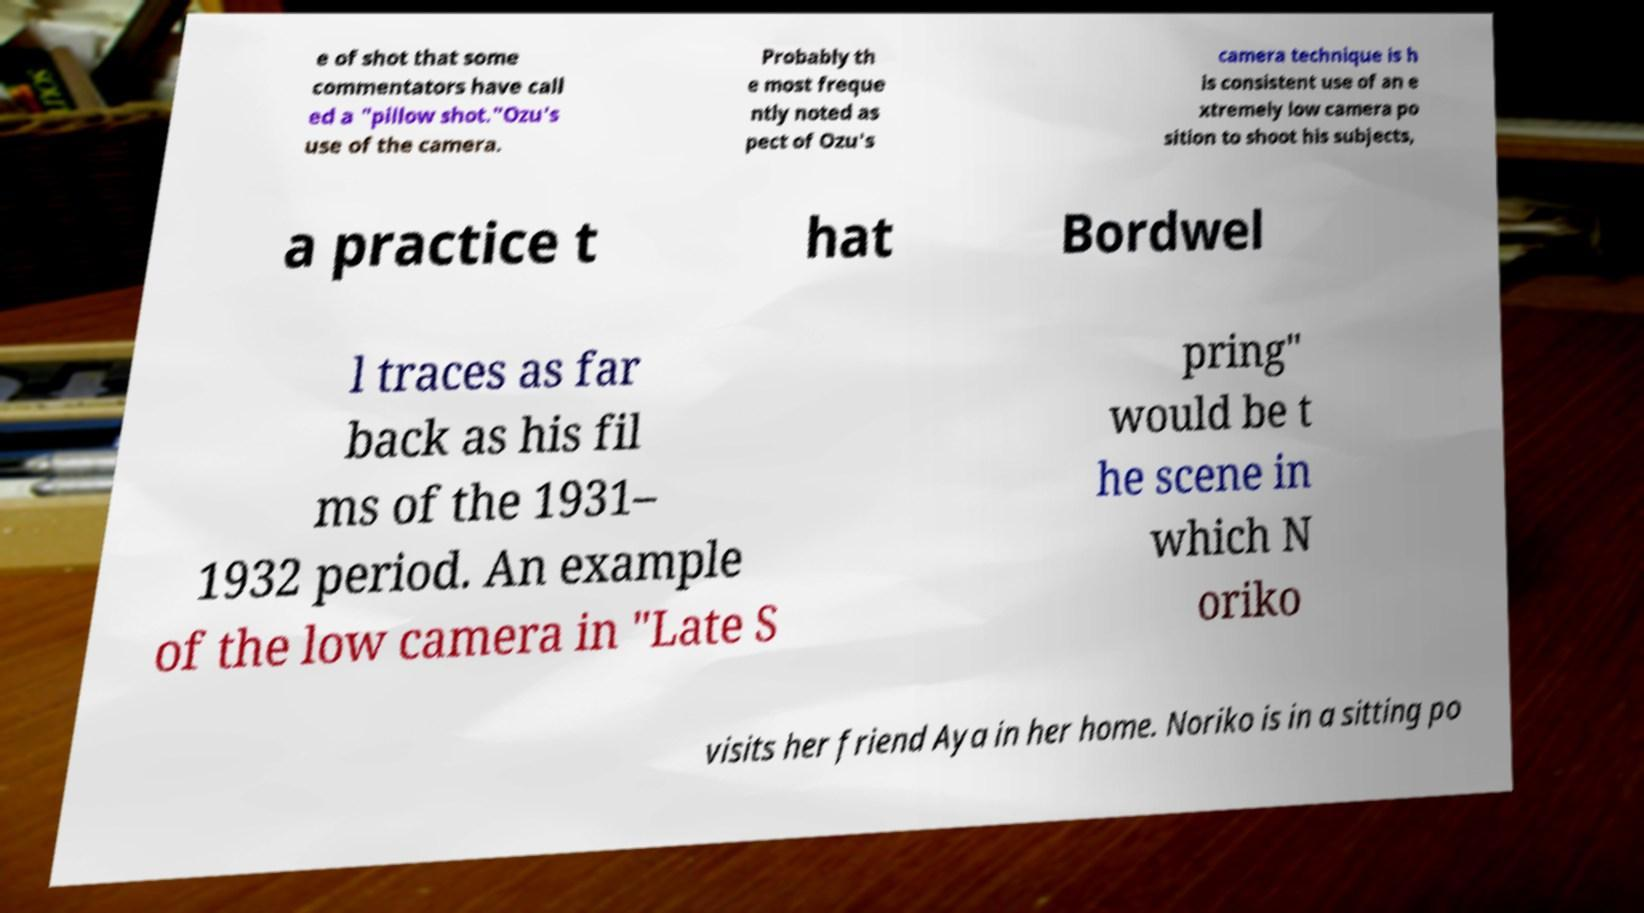Could you extract and type out the text from this image? e of shot that some commentators have call ed a "pillow shot."Ozu's use of the camera. Probably th e most freque ntly noted as pect of Ozu's camera technique is h is consistent use of an e xtremely low camera po sition to shoot his subjects, a practice t hat Bordwel l traces as far back as his fil ms of the 1931– 1932 period. An example of the low camera in "Late S pring" would be t he scene in which N oriko visits her friend Aya in her home. Noriko is in a sitting po 